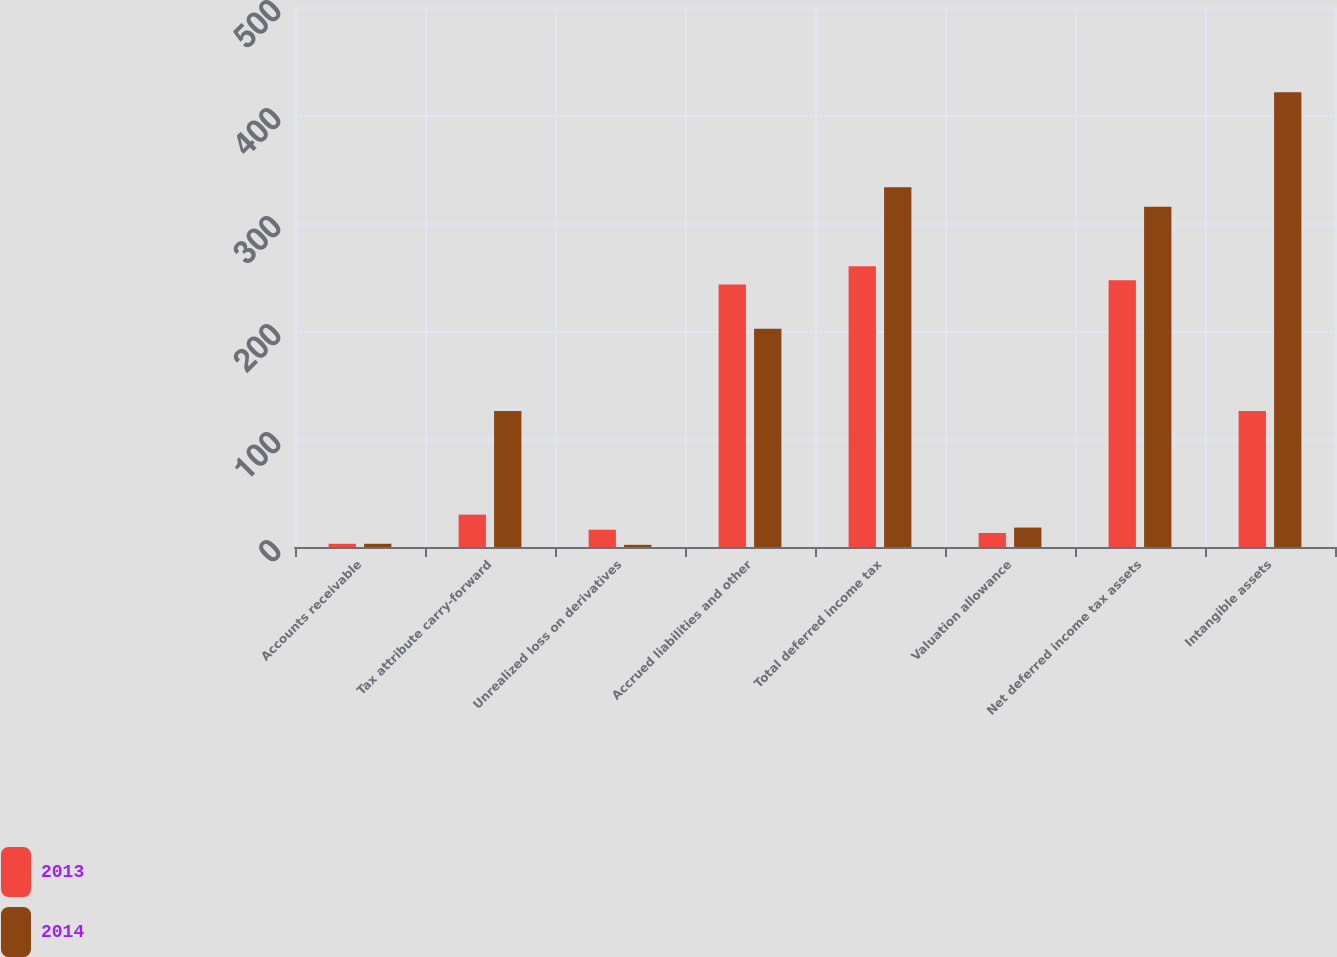<chart> <loc_0><loc_0><loc_500><loc_500><stacked_bar_chart><ecel><fcel>Accounts receivable<fcel>Tax attribute carry-forward<fcel>Unrealized loss on derivatives<fcel>Accrued liabilities and other<fcel>Total deferred income tax<fcel>Valuation allowance<fcel>Net deferred income tax assets<fcel>Intangible assets<nl><fcel>2013<fcel>3<fcel>30<fcel>16<fcel>243<fcel>260<fcel>13<fcel>247<fcel>126<nl><fcel>2014<fcel>3<fcel>126<fcel>2<fcel>202<fcel>333<fcel>18<fcel>315<fcel>421<nl></chart> 